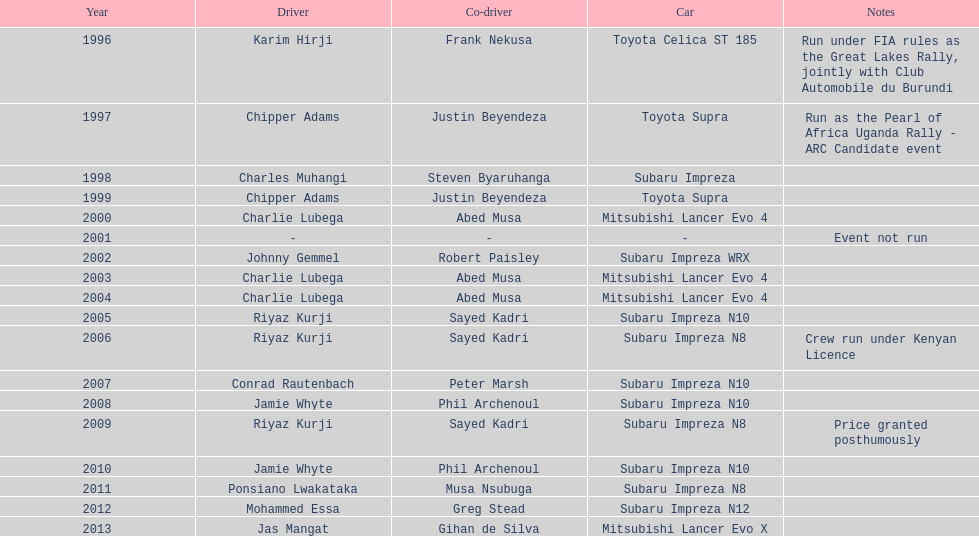What is the total number of wins for chipper adams and justin beyendeza? 2. Would you be able to parse every entry in this table? {'header': ['Year', 'Driver', 'Co-driver', 'Car', 'Notes'], 'rows': [['1996', 'Karim Hirji', 'Frank Nekusa', 'Toyota Celica ST 185', 'Run under FIA rules as the Great Lakes Rally, jointly with Club Automobile du Burundi'], ['1997', 'Chipper Adams', 'Justin Beyendeza', 'Toyota Supra', 'Run as the Pearl of Africa Uganda Rally - ARC Candidate event'], ['1998', 'Charles Muhangi', 'Steven Byaruhanga', 'Subaru Impreza', ''], ['1999', 'Chipper Adams', 'Justin Beyendeza', 'Toyota Supra', ''], ['2000', 'Charlie Lubega', 'Abed Musa', 'Mitsubishi Lancer Evo 4', ''], ['2001', '-', '-', '-', 'Event not run'], ['2002', 'Johnny Gemmel', 'Robert Paisley', 'Subaru Impreza WRX', ''], ['2003', 'Charlie Lubega', 'Abed Musa', 'Mitsubishi Lancer Evo 4', ''], ['2004', 'Charlie Lubega', 'Abed Musa', 'Mitsubishi Lancer Evo 4', ''], ['2005', 'Riyaz Kurji', 'Sayed Kadri', 'Subaru Impreza N10', ''], ['2006', 'Riyaz Kurji', 'Sayed Kadri', 'Subaru Impreza N8', 'Crew run under Kenyan Licence'], ['2007', 'Conrad Rautenbach', 'Peter Marsh', 'Subaru Impreza N10', ''], ['2008', 'Jamie Whyte', 'Phil Archenoul', 'Subaru Impreza N10', ''], ['2009', 'Riyaz Kurji', 'Sayed Kadri', 'Subaru Impreza N8', 'Price granted posthumously'], ['2010', 'Jamie Whyte', 'Phil Archenoul', 'Subaru Impreza N10', ''], ['2011', 'Ponsiano Lwakataka', 'Musa Nsubuga', 'Subaru Impreza N8', ''], ['2012', 'Mohammed Essa', 'Greg Stead', 'Subaru Impreza N12', ''], ['2013', 'Jas Mangat', 'Gihan de Silva', 'Mitsubishi Lancer Evo X', '']]} 